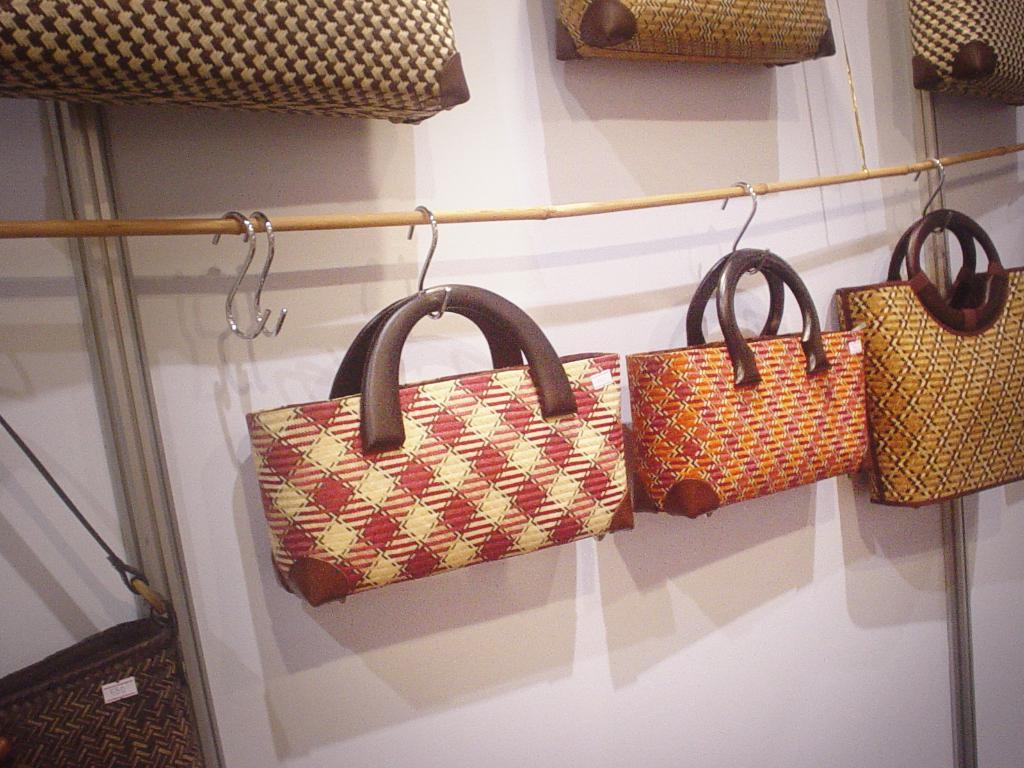What objects are visible in the image? There are bags in the image. How are the bags positioned in the image? The bags are hanged on a stick. What can be seen in the background of the image? There is a white wall in the background of the image. What type of question is being asked by the frogs in the image? There are no frogs present in the image, so it is not possible to determine what type of question they might be asking. 